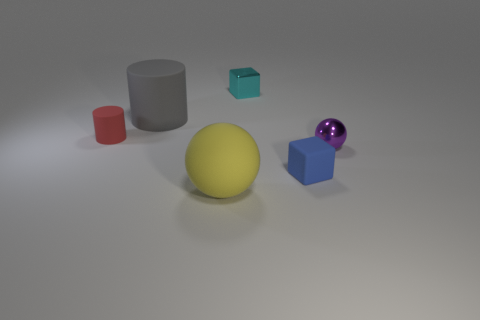What shape is the small matte thing that is on the right side of the tiny metallic thing behind the gray cylinder? The small matte object to the right of the tiny metallic object behind the gray cylinder is a cube. Its edges appear sharp and straight, characteristic of a cubic shape, and it has a turquoise hue. 